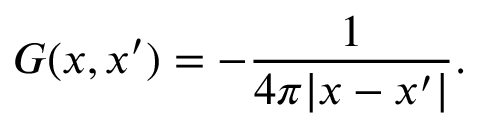<formula> <loc_0><loc_0><loc_500><loc_500>G ( x , x ^ { \prime } ) = - { \frac { 1 } { 4 \pi | x - x ^ { \prime } | } } .</formula> 